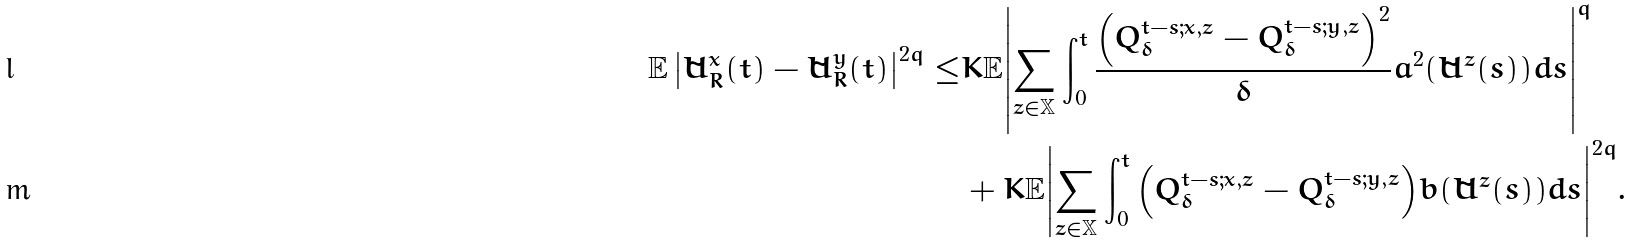<formula> <loc_0><loc_0><loc_500><loc_500>\mathbb { E } \left | \tilde { U } _ { R } ^ { x } ( t ) - \tilde { U } _ { R } ^ { y } ( t ) \right | ^ { 2 q } \leq & K \mathbb { E } { \left | \sum _ { z \in \mathbb { X } } \int _ { 0 } ^ { t } \frac { { \left ( Q ^ { t - s ; x , z } _ { \delta } - Q ^ { t - s ; y , z } _ { \delta } \right ) } ^ { 2 } } { \delta } a ^ { 2 } ( \tilde { U } ^ { z } ( s ) ) d s \right | } ^ { q } \\ & + K \mathbb { E } { \left | \sum _ { z \in \mathbb { X } } \int _ { 0 } ^ { t } { \left ( Q ^ { t - s ; x , z } _ { \delta } - Q ^ { t - s ; y , z } _ { \delta } \right ) } { b ( \tilde { U } ^ { z } ( s ) ) } d s \right | } ^ { 2 q } .</formula> 